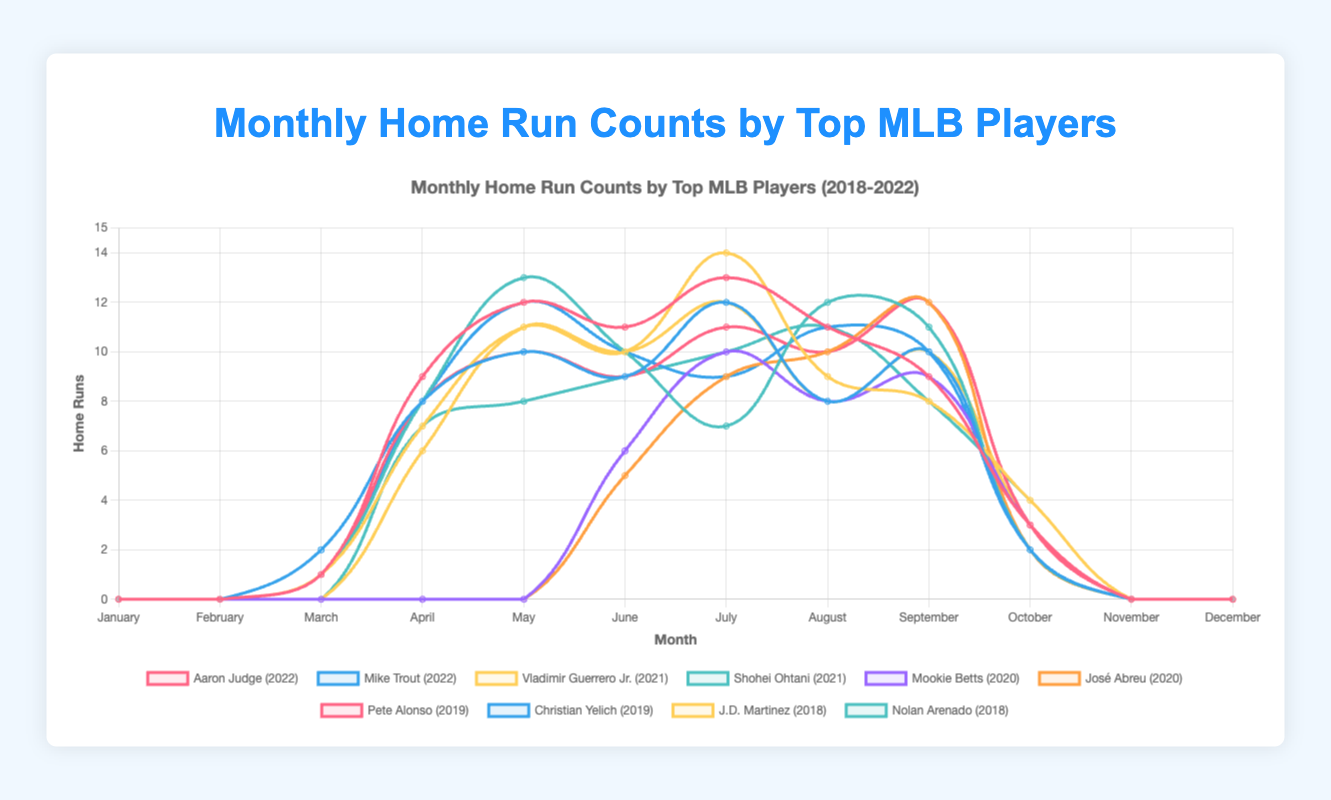Which player had the highest home run count in any single month? Shohei Ohtani had the highest monthly home run count, with 14 home runs in July 2021. We can tell this by observing the peak values on the plot.
Answer: Shohei Ohtani How many home runs did Aaron Judge hit in total from March to October in 2022? From March to October, Aaron Judge's home runs are 1 (March) + 9 (April) + 12 (May) + 11 (June) + 13 (July) + 11 (August) + 9 (September) + 3 (October). Adding these numbers gives 69.
Answer: 69 Which two players hit the same number of home runs in a specific month, and how many did they hit? In April, Aaron Judge (2022) and Mike Trout (2022) both hit 8 home runs. This is observed by comparing the same months across different players.
Answer: Aaron Judge and Mike Trout, 8 What is the average number of home runs hit by Vladimir Guerrero Jr. per month in 2021 from April to September? Vladimir Guerrero Jr.'s home runs from April to September are 7 (April) + 11 (May) + 10 (June) + 14 (July) + 9 (August) + 8 (September). The sum is 59, and the number of months is 6. The average is 59/6 = 9.83
Answer: 9.83 Which player had a noticeable increase in home runs from one month to the next? Aaron Judge had a noticeable increase from March (1 HR) to April (9 HR) in 2022, which is an increase of 8 HR.
Answer: Aaron Judge Who had the most consistent monthly home run count and in which year? Christian Yelich in 2019 appears to have the most consistent monthly home run count, with no drastic peaks or drops from month to month.
Answer: Christian Yelich, 2019 During the COVID-19 impacted 2020 season, which player had the highest increase in home runs between two consecutive months and what was the increase? José Abreu had the highest increase from August (10 HRs) to September (12 HRs), an increase of 2 home runs.
Answer: José Abreu, 2 Between Pete Alonso in 2019 and Shohei Ohtani in 2021, who hit more home runs in the month of September? Comparing the two, Pete Alonso hit 12 home runs in September 2019, whereas Shohei Ohtani hit 11 home runs in September 2021.
Answer: Pete Alonso Which player had the least number of home runs in any month while playing a full season, and which month was it? Checking the data, Mike Trout had the least, with 2 home runs in October 2022.
Answer: Mike Trout, October 